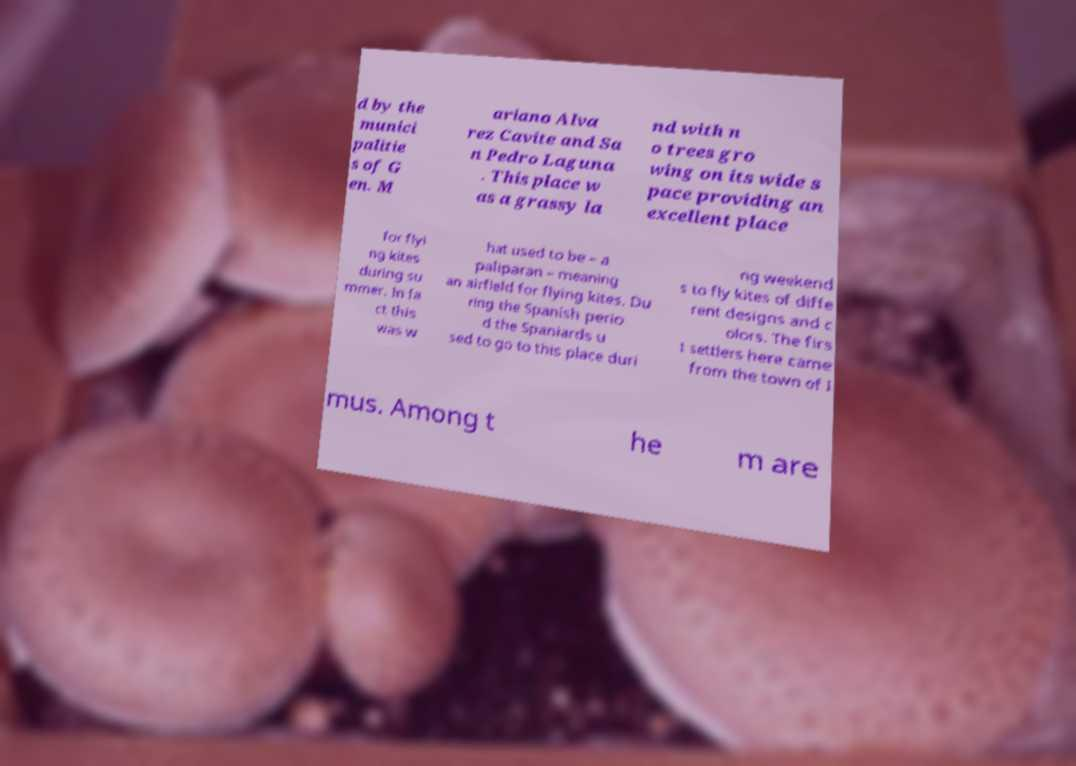Can you read and provide the text displayed in the image?This photo seems to have some interesting text. Can you extract and type it out for me? d by the munici palitie s of G en. M ariano Alva rez Cavite and Sa n Pedro Laguna . This place w as a grassy la nd with n o trees gro wing on its wide s pace providing an excellent place for flyi ng kites during su mmer. In fa ct this was w hat used to be – a paliparan – meaning an airfield for flying kites. Du ring the Spanish perio d the Spaniards u sed to go to this place duri ng weekend s to fly kites of diffe rent designs and c olors. The firs t settlers here came from the town of I mus. Among t he m are 